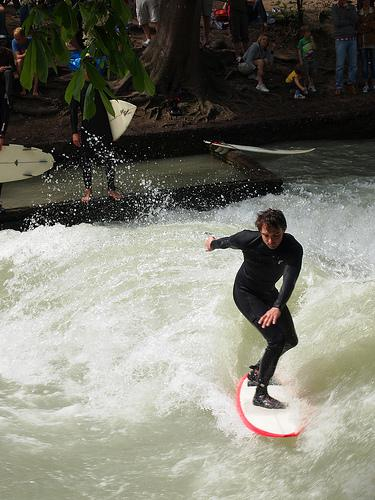Question: how many people are there?
Choices:
A. 12.
B. 13.
C. 14.
D. 15.
Answer with the letter. Answer: A Question: who took this picture?
Choices:
A. A tourist.
B. A parent.
C. A teacher.
D. A photographer.
Answer with the letter. Answer: A Question: where was this scene taken?
Choices:
A. Phillipines.
B. Hawaii.
C. Bali.
D. Thailand.
Answer with the letter. Answer: B 